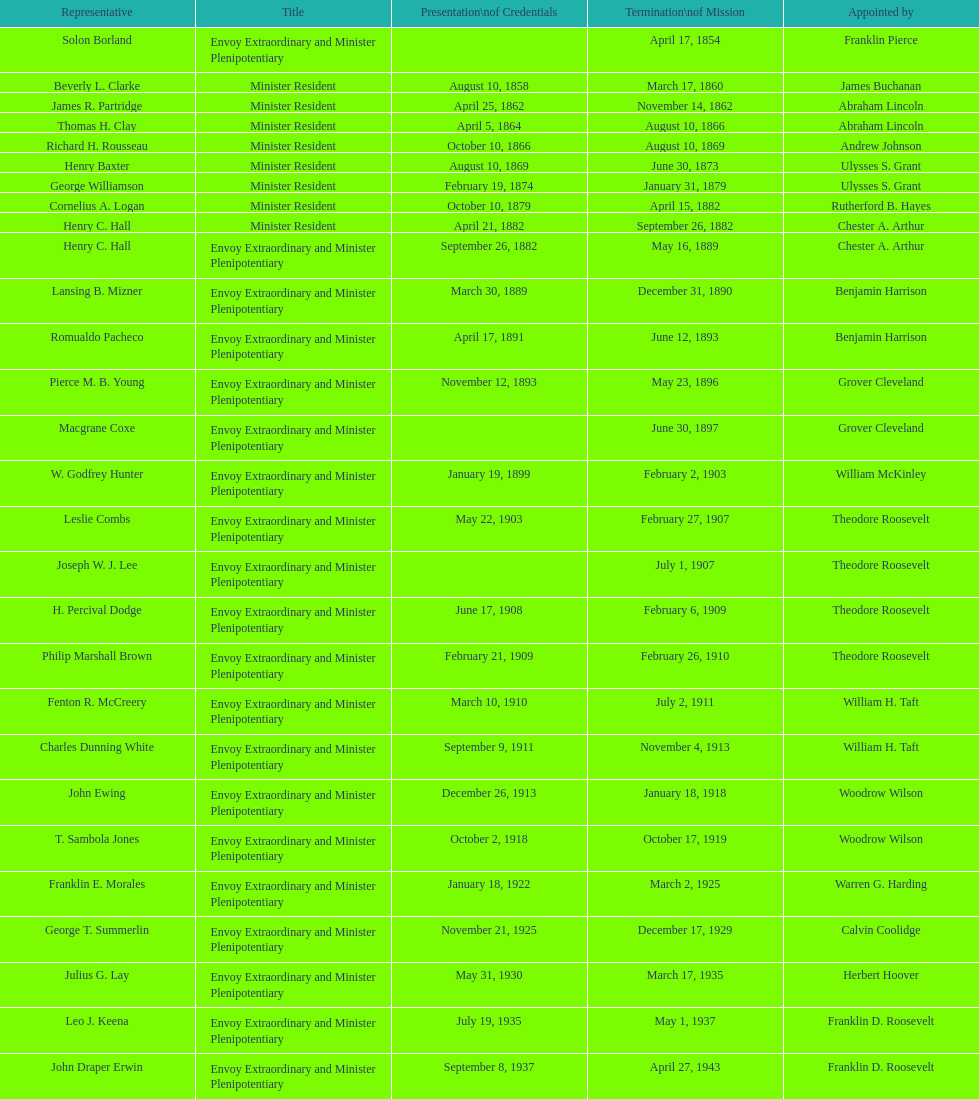How many representatives were appointed by theodore roosevelt? 4. Could you help me parse every detail presented in this table? {'header': ['Representative', 'Title', 'Presentation\\nof Credentials', 'Termination\\nof Mission', 'Appointed by'], 'rows': [['Solon Borland', 'Envoy Extraordinary and Minister Plenipotentiary', '', 'April 17, 1854', 'Franklin Pierce'], ['Beverly L. Clarke', 'Minister Resident', 'August 10, 1858', 'March 17, 1860', 'James Buchanan'], ['James R. Partridge', 'Minister Resident', 'April 25, 1862', 'November 14, 1862', 'Abraham Lincoln'], ['Thomas H. Clay', 'Minister Resident', 'April 5, 1864', 'August 10, 1866', 'Abraham Lincoln'], ['Richard H. Rousseau', 'Minister Resident', 'October 10, 1866', 'August 10, 1869', 'Andrew Johnson'], ['Henry Baxter', 'Minister Resident', 'August 10, 1869', 'June 30, 1873', 'Ulysses S. Grant'], ['George Williamson', 'Minister Resident', 'February 19, 1874', 'January 31, 1879', 'Ulysses S. Grant'], ['Cornelius A. Logan', 'Minister Resident', 'October 10, 1879', 'April 15, 1882', 'Rutherford B. Hayes'], ['Henry C. Hall', 'Minister Resident', 'April 21, 1882', 'September 26, 1882', 'Chester A. Arthur'], ['Henry C. Hall', 'Envoy Extraordinary and Minister Plenipotentiary', 'September 26, 1882', 'May 16, 1889', 'Chester A. Arthur'], ['Lansing B. Mizner', 'Envoy Extraordinary and Minister Plenipotentiary', 'March 30, 1889', 'December 31, 1890', 'Benjamin Harrison'], ['Romualdo Pacheco', 'Envoy Extraordinary and Minister Plenipotentiary', 'April 17, 1891', 'June 12, 1893', 'Benjamin Harrison'], ['Pierce M. B. Young', 'Envoy Extraordinary and Minister Plenipotentiary', 'November 12, 1893', 'May 23, 1896', 'Grover Cleveland'], ['Macgrane Coxe', 'Envoy Extraordinary and Minister Plenipotentiary', '', 'June 30, 1897', 'Grover Cleveland'], ['W. Godfrey Hunter', 'Envoy Extraordinary and Minister Plenipotentiary', 'January 19, 1899', 'February 2, 1903', 'William McKinley'], ['Leslie Combs', 'Envoy Extraordinary and Minister Plenipotentiary', 'May 22, 1903', 'February 27, 1907', 'Theodore Roosevelt'], ['Joseph W. J. Lee', 'Envoy Extraordinary and Minister Plenipotentiary', '', 'July 1, 1907', 'Theodore Roosevelt'], ['H. Percival Dodge', 'Envoy Extraordinary and Minister Plenipotentiary', 'June 17, 1908', 'February 6, 1909', 'Theodore Roosevelt'], ['Philip Marshall Brown', 'Envoy Extraordinary and Minister Plenipotentiary', 'February 21, 1909', 'February 26, 1910', 'Theodore Roosevelt'], ['Fenton R. McCreery', 'Envoy Extraordinary and Minister Plenipotentiary', 'March 10, 1910', 'July 2, 1911', 'William H. Taft'], ['Charles Dunning White', 'Envoy Extraordinary and Minister Plenipotentiary', 'September 9, 1911', 'November 4, 1913', 'William H. Taft'], ['John Ewing', 'Envoy Extraordinary and Minister Plenipotentiary', 'December 26, 1913', 'January 18, 1918', 'Woodrow Wilson'], ['T. Sambola Jones', 'Envoy Extraordinary and Minister Plenipotentiary', 'October 2, 1918', 'October 17, 1919', 'Woodrow Wilson'], ['Franklin E. Morales', 'Envoy Extraordinary and Minister Plenipotentiary', 'January 18, 1922', 'March 2, 1925', 'Warren G. Harding'], ['George T. Summerlin', 'Envoy Extraordinary and Minister Plenipotentiary', 'November 21, 1925', 'December 17, 1929', 'Calvin Coolidge'], ['Julius G. Lay', 'Envoy Extraordinary and Minister Plenipotentiary', 'May 31, 1930', 'March 17, 1935', 'Herbert Hoover'], ['Leo J. Keena', 'Envoy Extraordinary and Minister Plenipotentiary', 'July 19, 1935', 'May 1, 1937', 'Franklin D. Roosevelt'], ['John Draper Erwin', 'Envoy Extraordinary and Minister Plenipotentiary', 'September 8, 1937', 'April 27, 1943', 'Franklin D. Roosevelt'], ['John Draper Erwin', 'Ambassador Extraordinary and Plenipotentiary', 'April 27, 1943', 'April 16, 1947', 'Franklin D. Roosevelt'], ['Paul C. Daniels', 'Ambassador Extraordinary and Plenipotentiary', 'June 23, 1947', 'October 30, 1947', 'Harry S. Truman'], ['Herbert S. Bursley', 'Ambassador Extraordinary and Plenipotentiary', 'May 15, 1948', 'December 12, 1950', 'Harry S. Truman'], ['John Draper Erwin', 'Ambassador Extraordinary and Plenipotentiary', 'March 14, 1951', 'February 28, 1954', 'Harry S. Truman'], ['Whiting Willauer', 'Ambassador Extraordinary and Plenipotentiary', 'March 5, 1954', 'March 24, 1958', 'Dwight D. Eisenhower'], ['Robert Newbegin', 'Ambassador Extraordinary and Plenipotentiary', 'April 30, 1958', 'August 3, 1960', 'Dwight D. Eisenhower'], ['Charles R. Burrows', 'Ambassador Extraordinary and Plenipotentiary', 'November 3, 1960', 'June 28, 1965', 'Dwight D. Eisenhower'], ['Joseph J. Jova', 'Ambassador Extraordinary and Plenipotentiary', 'July 12, 1965', 'June 21, 1969', 'Lyndon B. Johnson'], ['Hewson A. Ryan', 'Ambassador Extraordinary and Plenipotentiary', 'November 5, 1969', 'May 30, 1973', 'Richard Nixon'], ['Phillip V. Sanchez', 'Ambassador Extraordinary and Plenipotentiary', 'June 15, 1973', 'July 17, 1976', 'Richard Nixon'], ['Ralph E. Becker', 'Ambassador Extraordinary and Plenipotentiary', 'October 27, 1976', 'August 1, 1977', 'Gerald Ford'], ['Mari-Luci Jaramillo', 'Ambassador Extraordinary and Plenipotentiary', 'October 27, 1977', 'September 19, 1980', 'Jimmy Carter'], ['Jack R. Binns', 'Ambassador Extraordinary and Plenipotentiary', 'October 10, 1980', 'October 31, 1981', 'Jimmy Carter'], ['John D. Negroponte', 'Ambassador Extraordinary and Plenipotentiary', 'November 11, 1981', 'May 30, 1985', 'Ronald Reagan'], ['John Arthur Ferch', 'Ambassador Extraordinary and Plenipotentiary', 'August 22, 1985', 'July 9, 1986', 'Ronald Reagan'], ['Everett Ellis Briggs', 'Ambassador Extraordinary and Plenipotentiary', 'November 4, 1986', 'June 15, 1989', 'Ronald Reagan'], ['Cresencio S. Arcos, Jr.', 'Ambassador Extraordinary and Plenipotentiary', 'January 29, 1990', 'July 1, 1993', 'George H. W. Bush'], ['William Thornton Pryce', 'Ambassador Extraordinary and Plenipotentiary', 'July 21, 1993', 'August 15, 1996', 'Bill Clinton'], ['James F. Creagan', 'Ambassador Extraordinary and Plenipotentiary', 'August 29, 1996', 'July 20, 1999', 'Bill Clinton'], ['Frank Almaguer', 'Ambassador Extraordinary and Plenipotentiary', 'August 25, 1999', 'September 5, 2002', 'Bill Clinton'], ['Larry Leon Palmer', 'Ambassador Extraordinary and Plenipotentiary', 'October 8, 2002', 'May 7, 2005', 'George W. Bush'], ['Charles A. Ford', 'Ambassador Extraordinary and Plenipotentiary', 'November 8, 2005', 'ca. April 2008', 'George W. Bush'], ['Hugo Llorens', 'Ambassador Extraordinary and Plenipotentiary', 'September 19, 2008', 'ca. July 2011', 'George W. Bush'], ['Lisa Kubiske', 'Ambassador Extraordinary and Plenipotentiary', 'July 26, 2011', 'Incumbent', 'Barack Obama']]} 